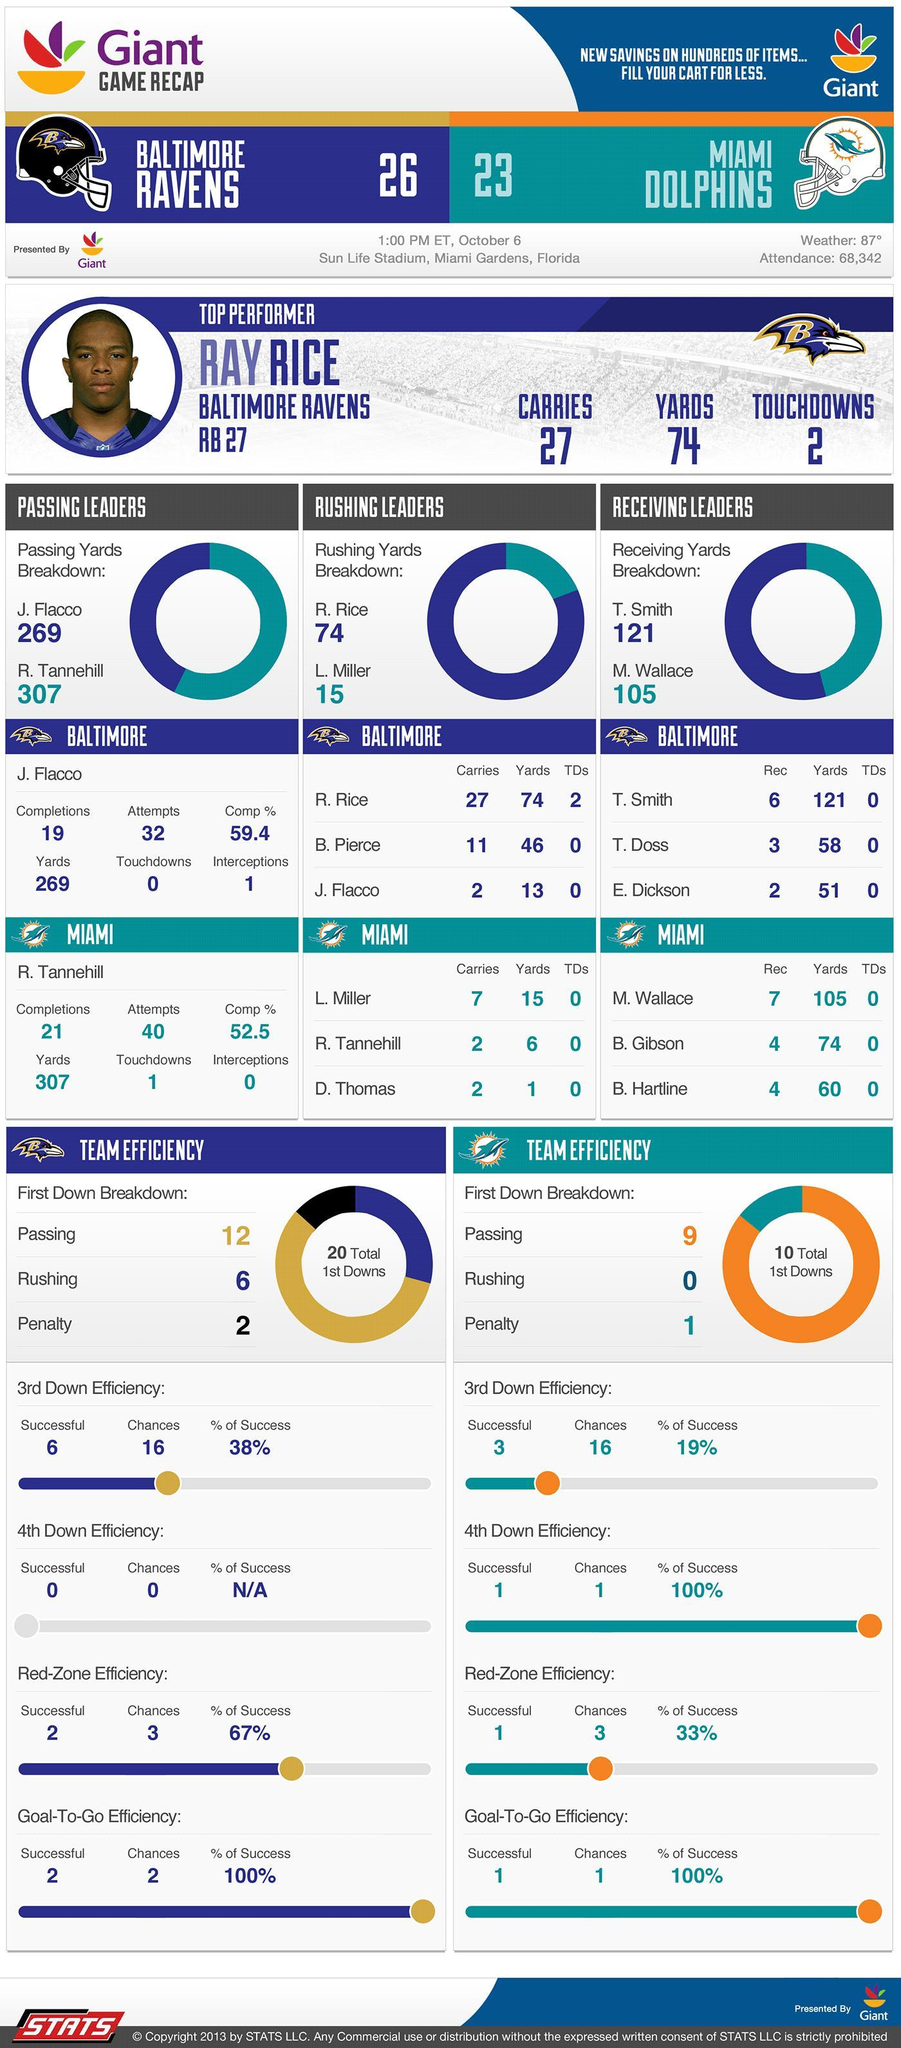How many people attended the Baltimore Ravens vs. Miami Dolphins NFL game on October 6, 2013?
Answer the question with a short phrase. 68,342 Who was the top performer in the Baltimore Ravens vs. Miami Dolphins NFL game on October 6, 2013? RAY RICE How many touchdowns were scored by Ray Rice in the game against Miami Dolphins on October 6, 2013? 2 